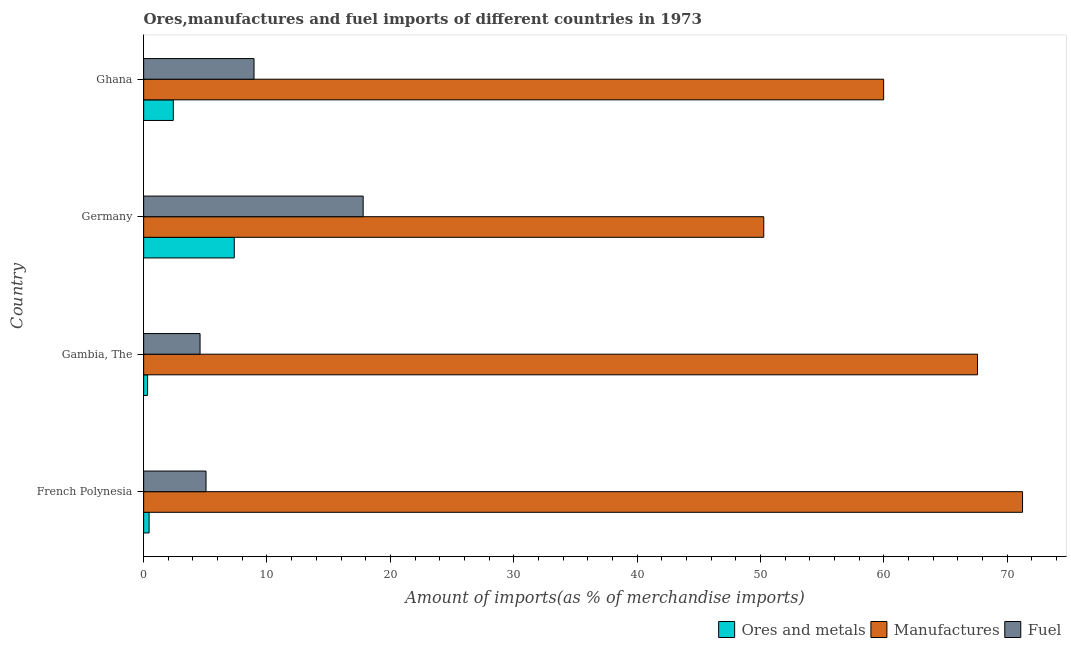How many different coloured bars are there?
Give a very brief answer. 3. How many groups of bars are there?
Offer a very short reply. 4. Are the number of bars on each tick of the Y-axis equal?
Give a very brief answer. Yes. How many bars are there on the 3rd tick from the top?
Ensure brevity in your answer.  3. How many bars are there on the 4th tick from the bottom?
Ensure brevity in your answer.  3. What is the label of the 2nd group of bars from the top?
Give a very brief answer. Germany. What is the percentage of ores and metals imports in Germany?
Ensure brevity in your answer.  7.35. Across all countries, what is the maximum percentage of fuel imports?
Your response must be concise. 17.8. Across all countries, what is the minimum percentage of ores and metals imports?
Your answer should be very brief. 0.32. In which country was the percentage of manufactures imports minimum?
Keep it short and to the point. Germany. What is the total percentage of fuel imports in the graph?
Offer a very short reply. 36.38. What is the difference between the percentage of manufactures imports in French Polynesia and that in Gambia, The?
Offer a very short reply. 3.65. What is the difference between the percentage of ores and metals imports in French Polynesia and the percentage of fuel imports in Germany?
Keep it short and to the point. -17.36. What is the average percentage of ores and metals imports per country?
Make the answer very short. 2.63. What is the difference between the percentage of manufactures imports and percentage of fuel imports in Germany?
Ensure brevity in your answer.  32.48. In how many countries, is the percentage of manufactures imports greater than 48 %?
Make the answer very short. 4. What is the ratio of the percentage of fuel imports in Gambia, The to that in Ghana?
Offer a very short reply. 0.51. Is the percentage of fuel imports in French Polynesia less than that in Ghana?
Keep it short and to the point. Yes. Is the difference between the percentage of fuel imports in Germany and Ghana greater than the difference between the percentage of ores and metals imports in Germany and Ghana?
Make the answer very short. Yes. What is the difference between the highest and the second highest percentage of ores and metals imports?
Your answer should be very brief. 4.94. What is the difference between the highest and the lowest percentage of fuel imports?
Give a very brief answer. 13.22. In how many countries, is the percentage of manufactures imports greater than the average percentage of manufactures imports taken over all countries?
Offer a terse response. 2. Is the sum of the percentage of ores and metals imports in French Polynesia and Ghana greater than the maximum percentage of manufactures imports across all countries?
Offer a terse response. No. What does the 2nd bar from the top in French Polynesia represents?
Make the answer very short. Manufactures. What does the 2nd bar from the bottom in Ghana represents?
Ensure brevity in your answer.  Manufactures. Is it the case that in every country, the sum of the percentage of ores and metals imports and percentage of manufactures imports is greater than the percentage of fuel imports?
Provide a short and direct response. Yes. How many countries are there in the graph?
Your answer should be compact. 4. Are the values on the major ticks of X-axis written in scientific E-notation?
Give a very brief answer. No. Does the graph contain any zero values?
Your answer should be compact. No. Does the graph contain grids?
Keep it short and to the point. No. Where does the legend appear in the graph?
Ensure brevity in your answer.  Bottom right. How are the legend labels stacked?
Keep it short and to the point. Horizontal. What is the title of the graph?
Provide a short and direct response. Ores,manufactures and fuel imports of different countries in 1973. Does "Ages 50+" appear as one of the legend labels in the graph?
Provide a succinct answer. No. What is the label or title of the X-axis?
Offer a terse response. Amount of imports(as % of merchandise imports). What is the label or title of the Y-axis?
Offer a very short reply. Country. What is the Amount of imports(as % of merchandise imports) in Ores and metals in French Polynesia?
Ensure brevity in your answer.  0.44. What is the Amount of imports(as % of merchandise imports) in Manufactures in French Polynesia?
Ensure brevity in your answer.  71.26. What is the Amount of imports(as % of merchandise imports) in Fuel in French Polynesia?
Keep it short and to the point. 5.06. What is the Amount of imports(as % of merchandise imports) in Ores and metals in Gambia, The?
Your answer should be very brief. 0.32. What is the Amount of imports(as % of merchandise imports) in Manufactures in Gambia, The?
Keep it short and to the point. 67.61. What is the Amount of imports(as % of merchandise imports) of Fuel in Gambia, The?
Ensure brevity in your answer.  4.57. What is the Amount of imports(as % of merchandise imports) of Ores and metals in Germany?
Your answer should be very brief. 7.35. What is the Amount of imports(as % of merchandise imports) in Manufactures in Germany?
Provide a short and direct response. 50.28. What is the Amount of imports(as % of merchandise imports) of Fuel in Germany?
Your answer should be compact. 17.8. What is the Amount of imports(as % of merchandise imports) in Ores and metals in Ghana?
Ensure brevity in your answer.  2.41. What is the Amount of imports(as % of merchandise imports) in Manufactures in Ghana?
Ensure brevity in your answer.  60. What is the Amount of imports(as % of merchandise imports) of Fuel in Ghana?
Keep it short and to the point. 8.95. Across all countries, what is the maximum Amount of imports(as % of merchandise imports) of Ores and metals?
Provide a short and direct response. 7.35. Across all countries, what is the maximum Amount of imports(as % of merchandise imports) of Manufactures?
Your answer should be compact. 71.26. Across all countries, what is the maximum Amount of imports(as % of merchandise imports) in Fuel?
Ensure brevity in your answer.  17.8. Across all countries, what is the minimum Amount of imports(as % of merchandise imports) in Ores and metals?
Your answer should be very brief. 0.32. Across all countries, what is the minimum Amount of imports(as % of merchandise imports) of Manufactures?
Offer a very short reply. 50.28. Across all countries, what is the minimum Amount of imports(as % of merchandise imports) in Fuel?
Give a very brief answer. 4.57. What is the total Amount of imports(as % of merchandise imports) in Ores and metals in the graph?
Offer a very short reply. 10.51. What is the total Amount of imports(as % of merchandise imports) in Manufactures in the graph?
Your answer should be very brief. 249.13. What is the total Amount of imports(as % of merchandise imports) in Fuel in the graph?
Keep it short and to the point. 36.38. What is the difference between the Amount of imports(as % of merchandise imports) of Ores and metals in French Polynesia and that in Gambia, The?
Offer a terse response. 0.12. What is the difference between the Amount of imports(as % of merchandise imports) in Manufactures in French Polynesia and that in Gambia, The?
Offer a terse response. 3.65. What is the difference between the Amount of imports(as % of merchandise imports) in Fuel in French Polynesia and that in Gambia, The?
Your answer should be compact. 0.48. What is the difference between the Amount of imports(as % of merchandise imports) in Ores and metals in French Polynesia and that in Germany?
Your response must be concise. -6.91. What is the difference between the Amount of imports(as % of merchandise imports) of Manufactures in French Polynesia and that in Germany?
Your answer should be compact. 20.98. What is the difference between the Amount of imports(as % of merchandise imports) of Fuel in French Polynesia and that in Germany?
Offer a very short reply. -12.74. What is the difference between the Amount of imports(as % of merchandise imports) of Ores and metals in French Polynesia and that in Ghana?
Keep it short and to the point. -1.96. What is the difference between the Amount of imports(as % of merchandise imports) in Manufactures in French Polynesia and that in Ghana?
Ensure brevity in your answer.  11.26. What is the difference between the Amount of imports(as % of merchandise imports) of Fuel in French Polynesia and that in Ghana?
Ensure brevity in your answer.  -3.89. What is the difference between the Amount of imports(as % of merchandise imports) of Ores and metals in Gambia, The and that in Germany?
Provide a short and direct response. -7.03. What is the difference between the Amount of imports(as % of merchandise imports) in Manufactures in Gambia, The and that in Germany?
Make the answer very short. 17.33. What is the difference between the Amount of imports(as % of merchandise imports) in Fuel in Gambia, The and that in Germany?
Offer a very short reply. -13.22. What is the difference between the Amount of imports(as % of merchandise imports) in Ores and metals in Gambia, The and that in Ghana?
Your response must be concise. -2.09. What is the difference between the Amount of imports(as % of merchandise imports) in Manufactures in Gambia, The and that in Ghana?
Provide a short and direct response. 7.61. What is the difference between the Amount of imports(as % of merchandise imports) of Fuel in Gambia, The and that in Ghana?
Give a very brief answer. -4.37. What is the difference between the Amount of imports(as % of merchandise imports) in Ores and metals in Germany and that in Ghana?
Your answer should be compact. 4.94. What is the difference between the Amount of imports(as % of merchandise imports) in Manufactures in Germany and that in Ghana?
Offer a very short reply. -9.72. What is the difference between the Amount of imports(as % of merchandise imports) of Fuel in Germany and that in Ghana?
Give a very brief answer. 8.85. What is the difference between the Amount of imports(as % of merchandise imports) of Ores and metals in French Polynesia and the Amount of imports(as % of merchandise imports) of Manufactures in Gambia, The?
Keep it short and to the point. -67.17. What is the difference between the Amount of imports(as % of merchandise imports) in Ores and metals in French Polynesia and the Amount of imports(as % of merchandise imports) in Fuel in Gambia, The?
Offer a terse response. -4.13. What is the difference between the Amount of imports(as % of merchandise imports) of Manufactures in French Polynesia and the Amount of imports(as % of merchandise imports) of Fuel in Gambia, The?
Make the answer very short. 66.68. What is the difference between the Amount of imports(as % of merchandise imports) of Ores and metals in French Polynesia and the Amount of imports(as % of merchandise imports) of Manufactures in Germany?
Give a very brief answer. -49.83. What is the difference between the Amount of imports(as % of merchandise imports) of Ores and metals in French Polynesia and the Amount of imports(as % of merchandise imports) of Fuel in Germany?
Your response must be concise. -17.36. What is the difference between the Amount of imports(as % of merchandise imports) in Manufactures in French Polynesia and the Amount of imports(as % of merchandise imports) in Fuel in Germany?
Offer a terse response. 53.46. What is the difference between the Amount of imports(as % of merchandise imports) in Ores and metals in French Polynesia and the Amount of imports(as % of merchandise imports) in Manufactures in Ghana?
Keep it short and to the point. -59.55. What is the difference between the Amount of imports(as % of merchandise imports) of Ores and metals in French Polynesia and the Amount of imports(as % of merchandise imports) of Fuel in Ghana?
Provide a short and direct response. -8.51. What is the difference between the Amount of imports(as % of merchandise imports) of Manufactures in French Polynesia and the Amount of imports(as % of merchandise imports) of Fuel in Ghana?
Offer a terse response. 62.31. What is the difference between the Amount of imports(as % of merchandise imports) of Ores and metals in Gambia, The and the Amount of imports(as % of merchandise imports) of Manufactures in Germany?
Provide a succinct answer. -49.96. What is the difference between the Amount of imports(as % of merchandise imports) in Ores and metals in Gambia, The and the Amount of imports(as % of merchandise imports) in Fuel in Germany?
Ensure brevity in your answer.  -17.48. What is the difference between the Amount of imports(as % of merchandise imports) of Manufactures in Gambia, The and the Amount of imports(as % of merchandise imports) of Fuel in Germany?
Your answer should be compact. 49.81. What is the difference between the Amount of imports(as % of merchandise imports) of Ores and metals in Gambia, The and the Amount of imports(as % of merchandise imports) of Manufactures in Ghana?
Make the answer very short. -59.67. What is the difference between the Amount of imports(as % of merchandise imports) in Ores and metals in Gambia, The and the Amount of imports(as % of merchandise imports) in Fuel in Ghana?
Keep it short and to the point. -8.63. What is the difference between the Amount of imports(as % of merchandise imports) in Manufactures in Gambia, The and the Amount of imports(as % of merchandise imports) in Fuel in Ghana?
Provide a short and direct response. 58.66. What is the difference between the Amount of imports(as % of merchandise imports) in Ores and metals in Germany and the Amount of imports(as % of merchandise imports) in Manufactures in Ghana?
Your answer should be compact. -52.65. What is the difference between the Amount of imports(as % of merchandise imports) in Ores and metals in Germany and the Amount of imports(as % of merchandise imports) in Fuel in Ghana?
Provide a succinct answer. -1.6. What is the difference between the Amount of imports(as % of merchandise imports) of Manufactures in Germany and the Amount of imports(as % of merchandise imports) of Fuel in Ghana?
Make the answer very short. 41.33. What is the average Amount of imports(as % of merchandise imports) of Ores and metals per country?
Keep it short and to the point. 2.63. What is the average Amount of imports(as % of merchandise imports) of Manufactures per country?
Provide a short and direct response. 62.28. What is the average Amount of imports(as % of merchandise imports) of Fuel per country?
Your response must be concise. 9.09. What is the difference between the Amount of imports(as % of merchandise imports) in Ores and metals and Amount of imports(as % of merchandise imports) in Manufactures in French Polynesia?
Your response must be concise. -70.82. What is the difference between the Amount of imports(as % of merchandise imports) of Ores and metals and Amount of imports(as % of merchandise imports) of Fuel in French Polynesia?
Ensure brevity in your answer.  -4.62. What is the difference between the Amount of imports(as % of merchandise imports) in Manufactures and Amount of imports(as % of merchandise imports) in Fuel in French Polynesia?
Give a very brief answer. 66.2. What is the difference between the Amount of imports(as % of merchandise imports) in Ores and metals and Amount of imports(as % of merchandise imports) in Manufactures in Gambia, The?
Provide a succinct answer. -67.29. What is the difference between the Amount of imports(as % of merchandise imports) of Ores and metals and Amount of imports(as % of merchandise imports) of Fuel in Gambia, The?
Your answer should be very brief. -4.25. What is the difference between the Amount of imports(as % of merchandise imports) of Manufactures and Amount of imports(as % of merchandise imports) of Fuel in Gambia, The?
Ensure brevity in your answer.  63.03. What is the difference between the Amount of imports(as % of merchandise imports) in Ores and metals and Amount of imports(as % of merchandise imports) in Manufactures in Germany?
Offer a terse response. -42.93. What is the difference between the Amount of imports(as % of merchandise imports) of Ores and metals and Amount of imports(as % of merchandise imports) of Fuel in Germany?
Your answer should be compact. -10.45. What is the difference between the Amount of imports(as % of merchandise imports) in Manufactures and Amount of imports(as % of merchandise imports) in Fuel in Germany?
Offer a terse response. 32.48. What is the difference between the Amount of imports(as % of merchandise imports) of Ores and metals and Amount of imports(as % of merchandise imports) of Manufactures in Ghana?
Give a very brief answer. -57.59. What is the difference between the Amount of imports(as % of merchandise imports) of Ores and metals and Amount of imports(as % of merchandise imports) of Fuel in Ghana?
Your answer should be compact. -6.54. What is the difference between the Amount of imports(as % of merchandise imports) of Manufactures and Amount of imports(as % of merchandise imports) of Fuel in Ghana?
Your answer should be very brief. 51.05. What is the ratio of the Amount of imports(as % of merchandise imports) of Ores and metals in French Polynesia to that in Gambia, The?
Your response must be concise. 1.38. What is the ratio of the Amount of imports(as % of merchandise imports) of Manufactures in French Polynesia to that in Gambia, The?
Offer a terse response. 1.05. What is the ratio of the Amount of imports(as % of merchandise imports) in Fuel in French Polynesia to that in Gambia, The?
Provide a succinct answer. 1.11. What is the ratio of the Amount of imports(as % of merchandise imports) in Ores and metals in French Polynesia to that in Germany?
Make the answer very short. 0.06. What is the ratio of the Amount of imports(as % of merchandise imports) of Manufactures in French Polynesia to that in Germany?
Your answer should be very brief. 1.42. What is the ratio of the Amount of imports(as % of merchandise imports) in Fuel in French Polynesia to that in Germany?
Your answer should be very brief. 0.28. What is the ratio of the Amount of imports(as % of merchandise imports) of Ores and metals in French Polynesia to that in Ghana?
Offer a very short reply. 0.18. What is the ratio of the Amount of imports(as % of merchandise imports) in Manufactures in French Polynesia to that in Ghana?
Give a very brief answer. 1.19. What is the ratio of the Amount of imports(as % of merchandise imports) of Fuel in French Polynesia to that in Ghana?
Make the answer very short. 0.57. What is the ratio of the Amount of imports(as % of merchandise imports) of Ores and metals in Gambia, The to that in Germany?
Your answer should be compact. 0.04. What is the ratio of the Amount of imports(as % of merchandise imports) in Manufactures in Gambia, The to that in Germany?
Make the answer very short. 1.34. What is the ratio of the Amount of imports(as % of merchandise imports) of Fuel in Gambia, The to that in Germany?
Provide a succinct answer. 0.26. What is the ratio of the Amount of imports(as % of merchandise imports) of Ores and metals in Gambia, The to that in Ghana?
Make the answer very short. 0.13. What is the ratio of the Amount of imports(as % of merchandise imports) of Manufactures in Gambia, The to that in Ghana?
Give a very brief answer. 1.13. What is the ratio of the Amount of imports(as % of merchandise imports) in Fuel in Gambia, The to that in Ghana?
Ensure brevity in your answer.  0.51. What is the ratio of the Amount of imports(as % of merchandise imports) of Ores and metals in Germany to that in Ghana?
Provide a succinct answer. 3.05. What is the ratio of the Amount of imports(as % of merchandise imports) in Manufactures in Germany to that in Ghana?
Ensure brevity in your answer.  0.84. What is the ratio of the Amount of imports(as % of merchandise imports) of Fuel in Germany to that in Ghana?
Offer a terse response. 1.99. What is the difference between the highest and the second highest Amount of imports(as % of merchandise imports) in Ores and metals?
Provide a short and direct response. 4.94. What is the difference between the highest and the second highest Amount of imports(as % of merchandise imports) of Manufactures?
Make the answer very short. 3.65. What is the difference between the highest and the second highest Amount of imports(as % of merchandise imports) of Fuel?
Your answer should be very brief. 8.85. What is the difference between the highest and the lowest Amount of imports(as % of merchandise imports) of Ores and metals?
Your answer should be compact. 7.03. What is the difference between the highest and the lowest Amount of imports(as % of merchandise imports) in Manufactures?
Offer a terse response. 20.98. What is the difference between the highest and the lowest Amount of imports(as % of merchandise imports) of Fuel?
Give a very brief answer. 13.22. 